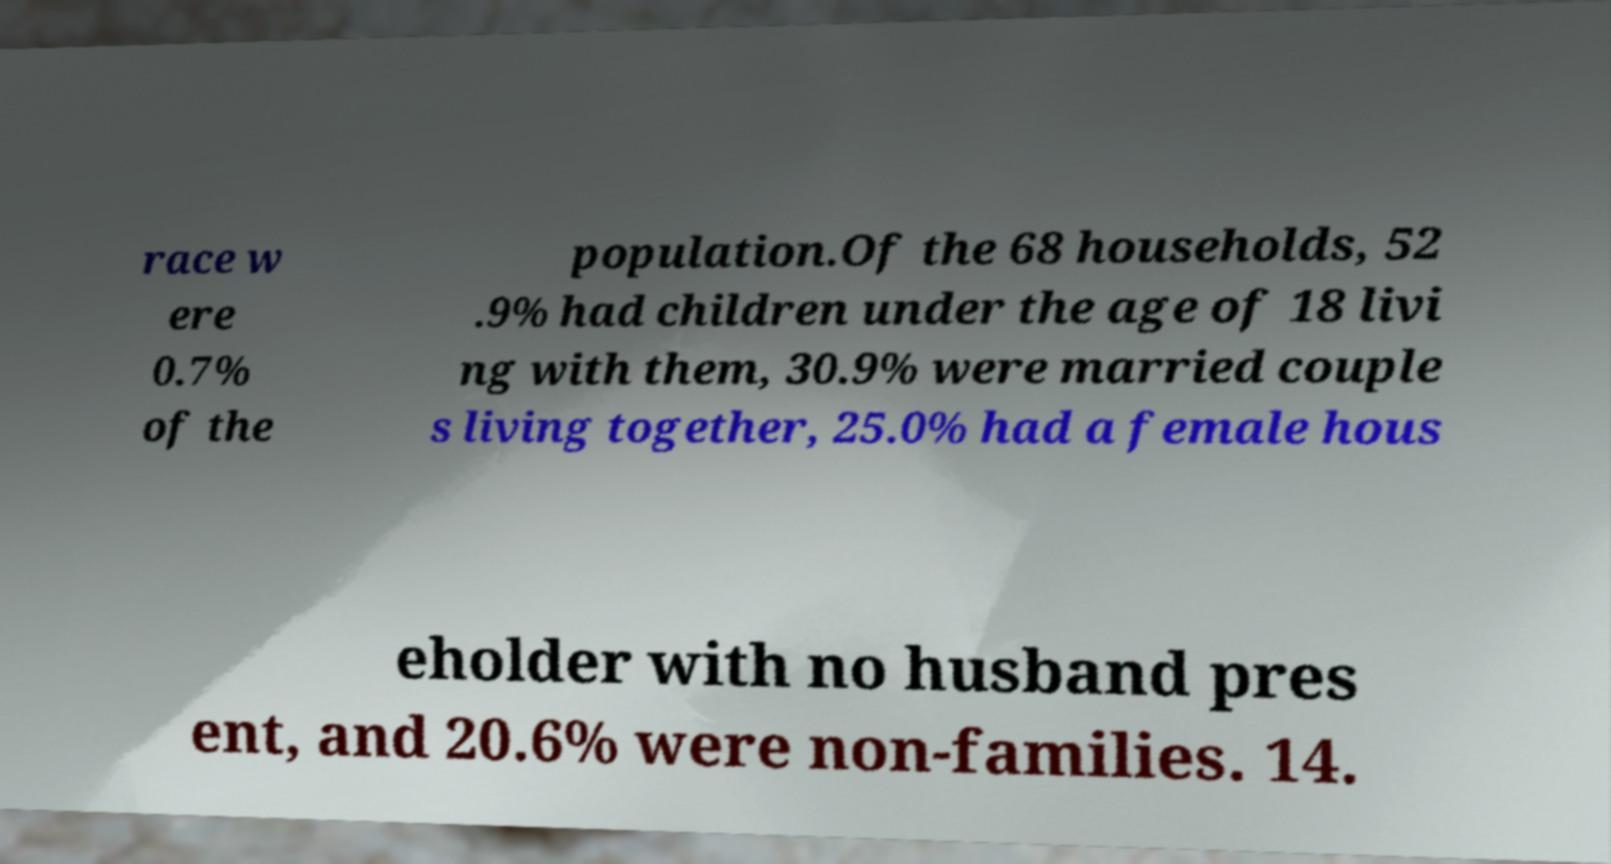Can you read and provide the text displayed in the image?This photo seems to have some interesting text. Can you extract and type it out for me? race w ere 0.7% of the population.Of the 68 households, 52 .9% had children under the age of 18 livi ng with them, 30.9% were married couple s living together, 25.0% had a female hous eholder with no husband pres ent, and 20.6% were non-families. 14. 